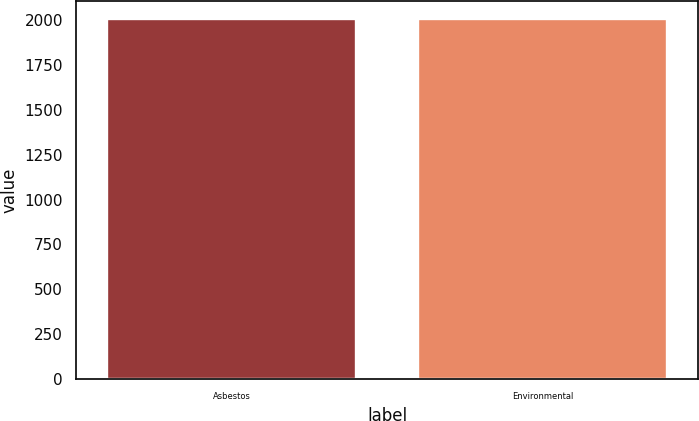Convert chart. <chart><loc_0><loc_0><loc_500><loc_500><bar_chart><fcel>Asbestos<fcel>Environmental<nl><fcel>2003<fcel>2003.1<nl></chart> 